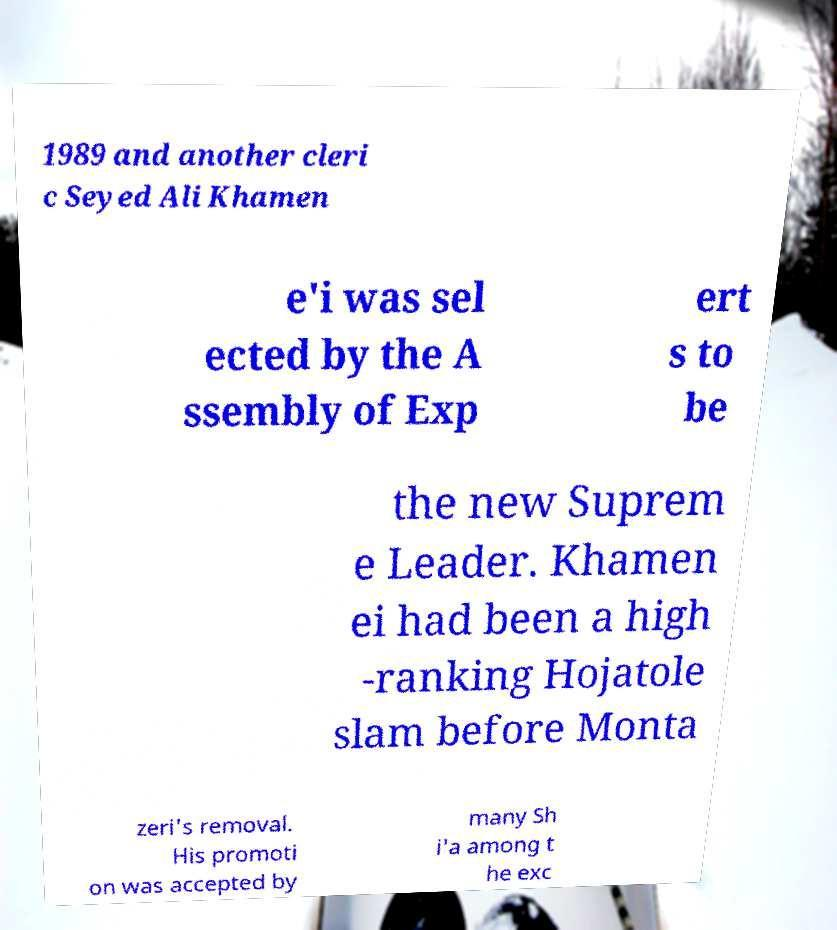Can you read and provide the text displayed in the image?This photo seems to have some interesting text. Can you extract and type it out for me? 1989 and another cleri c Seyed Ali Khamen e'i was sel ected by the A ssembly of Exp ert s to be the new Suprem e Leader. Khamen ei had been a high -ranking Hojatole slam before Monta zeri's removal. His promoti on was accepted by many Sh i'a among t he exc 